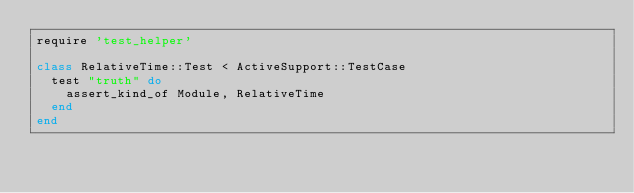<code> <loc_0><loc_0><loc_500><loc_500><_Ruby_>require 'test_helper'

class RelativeTime::Test < ActiveSupport::TestCase
  test "truth" do
    assert_kind_of Module, RelativeTime
  end
end
</code> 